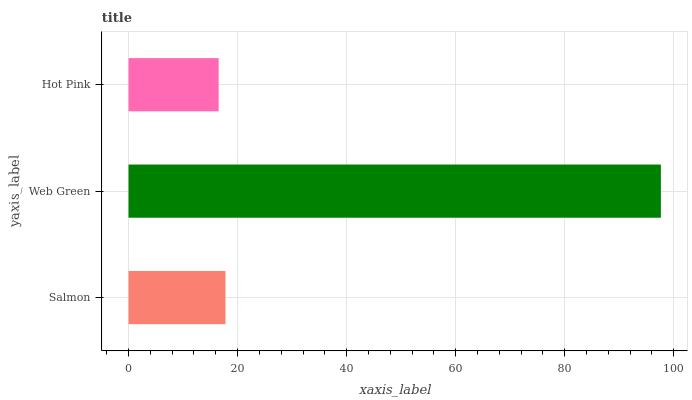Is Hot Pink the minimum?
Answer yes or no. Yes. Is Web Green the maximum?
Answer yes or no. Yes. Is Web Green the minimum?
Answer yes or no. No. Is Hot Pink the maximum?
Answer yes or no. No. Is Web Green greater than Hot Pink?
Answer yes or no. Yes. Is Hot Pink less than Web Green?
Answer yes or no. Yes. Is Hot Pink greater than Web Green?
Answer yes or no. No. Is Web Green less than Hot Pink?
Answer yes or no. No. Is Salmon the high median?
Answer yes or no. Yes. Is Salmon the low median?
Answer yes or no. Yes. Is Web Green the high median?
Answer yes or no. No. Is Hot Pink the low median?
Answer yes or no. No. 